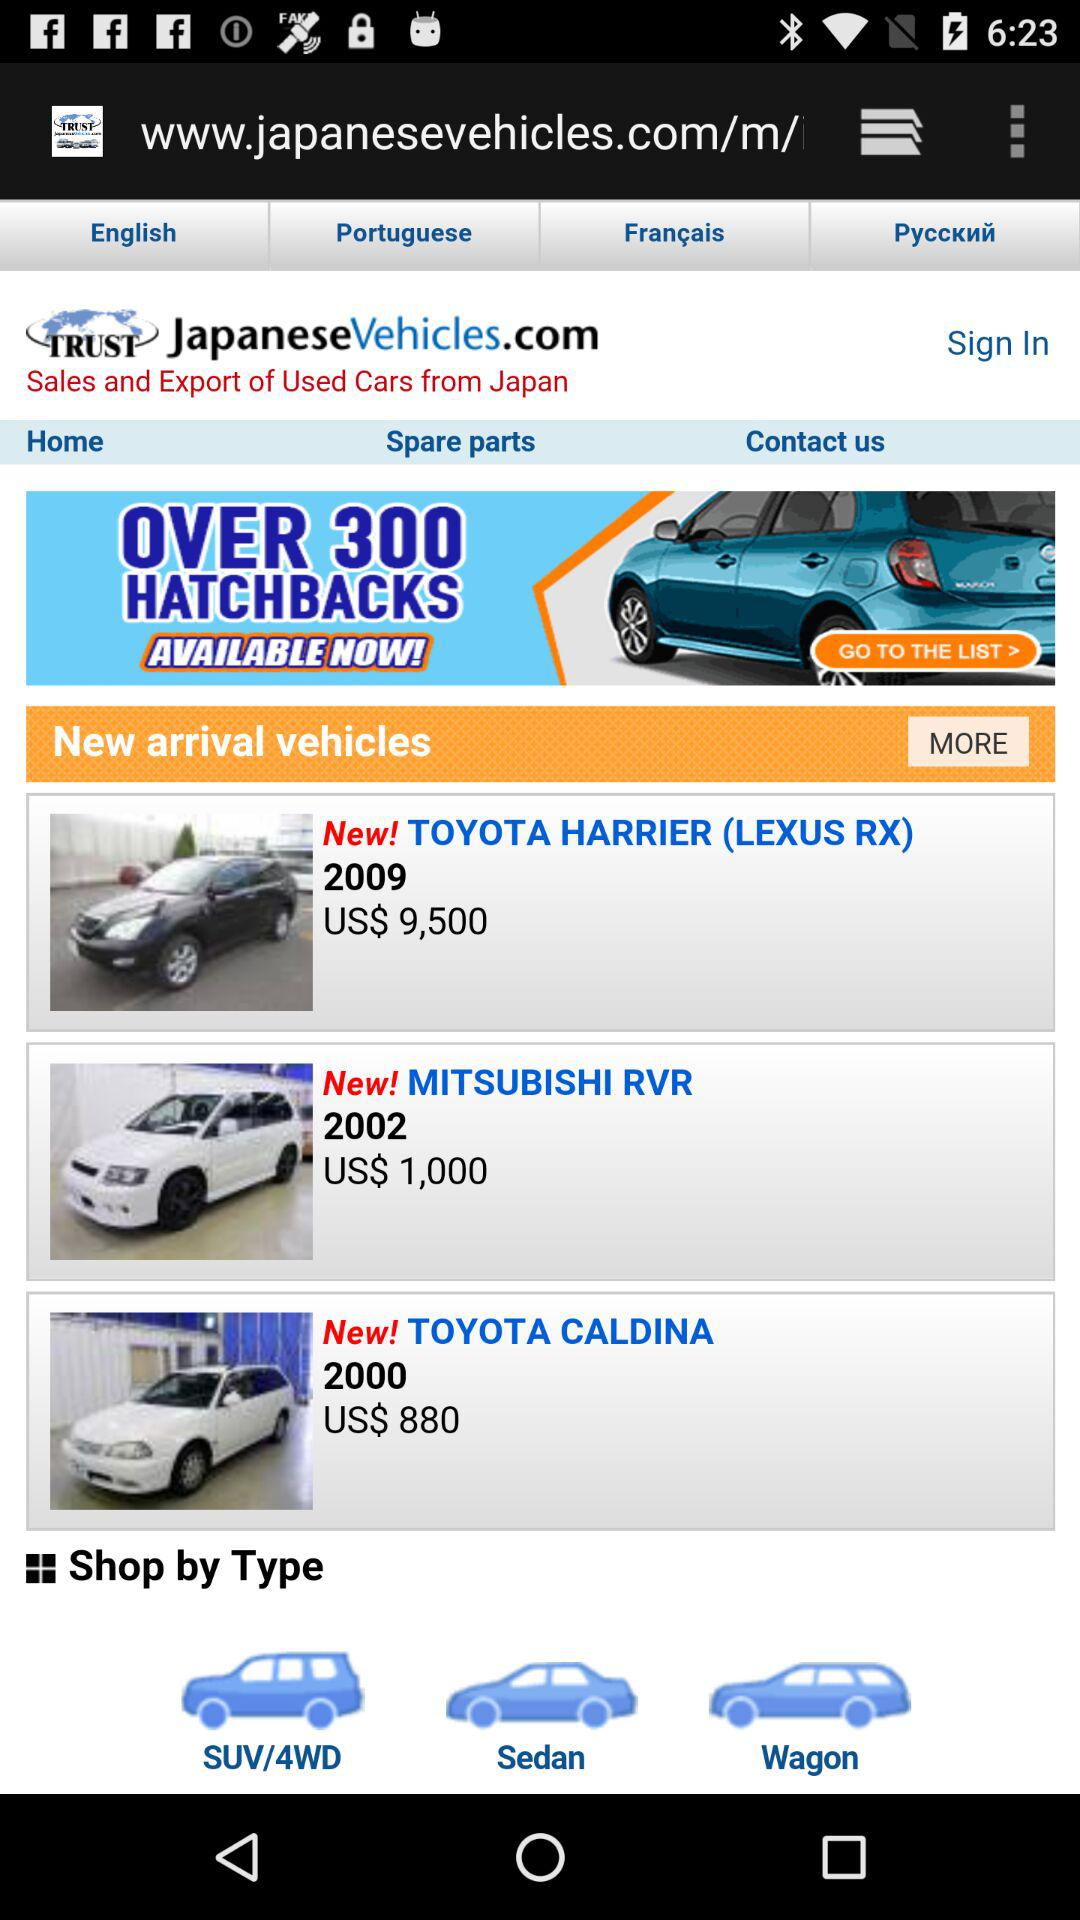What is the model of the Toyota Harrier? The model is "LEXUS RX". 